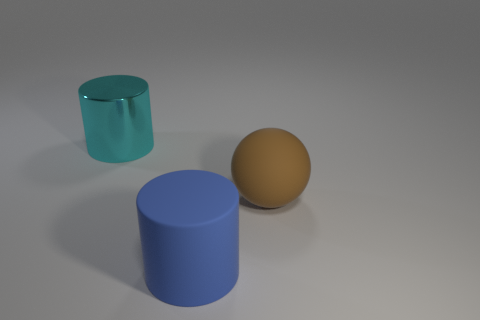Is there anything else that has the same material as the cyan cylinder?
Give a very brief answer. No. What is the color of the other thing that is the same material as the brown object?
Provide a short and direct response. Blue. Is there a brown ball of the same size as the brown matte thing?
Your response must be concise. No. What number of objects are large cylinders behind the large ball or matte things that are to the right of the big blue matte thing?
Provide a short and direct response. 2. There is a metallic thing that is the same size as the brown rubber object; what is its shape?
Offer a very short reply. Cylinder. Is there another matte thing of the same shape as the large cyan thing?
Ensure brevity in your answer.  Yes. Are there fewer big cyan metal objects than tiny cylinders?
Your answer should be compact. No. Does the cylinder that is right of the large cyan cylinder have the same size as the cylinder behind the brown matte object?
Offer a very short reply. Yes. What number of objects are tiny brown rubber cylinders or large brown spheres?
Provide a succinct answer. 1. There is a object that is behind the big sphere; how big is it?
Make the answer very short. Large. 